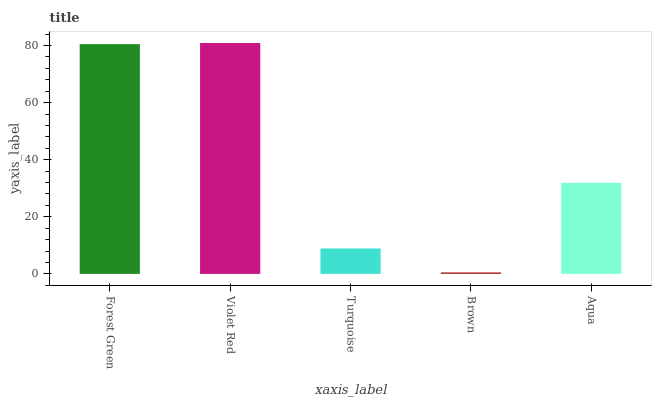Is Brown the minimum?
Answer yes or no. Yes. Is Violet Red the maximum?
Answer yes or no. Yes. Is Turquoise the minimum?
Answer yes or no. No. Is Turquoise the maximum?
Answer yes or no. No. Is Violet Red greater than Turquoise?
Answer yes or no. Yes. Is Turquoise less than Violet Red?
Answer yes or no. Yes. Is Turquoise greater than Violet Red?
Answer yes or no. No. Is Violet Red less than Turquoise?
Answer yes or no. No. Is Aqua the high median?
Answer yes or no. Yes. Is Aqua the low median?
Answer yes or no. Yes. Is Brown the high median?
Answer yes or no. No. Is Brown the low median?
Answer yes or no. No. 